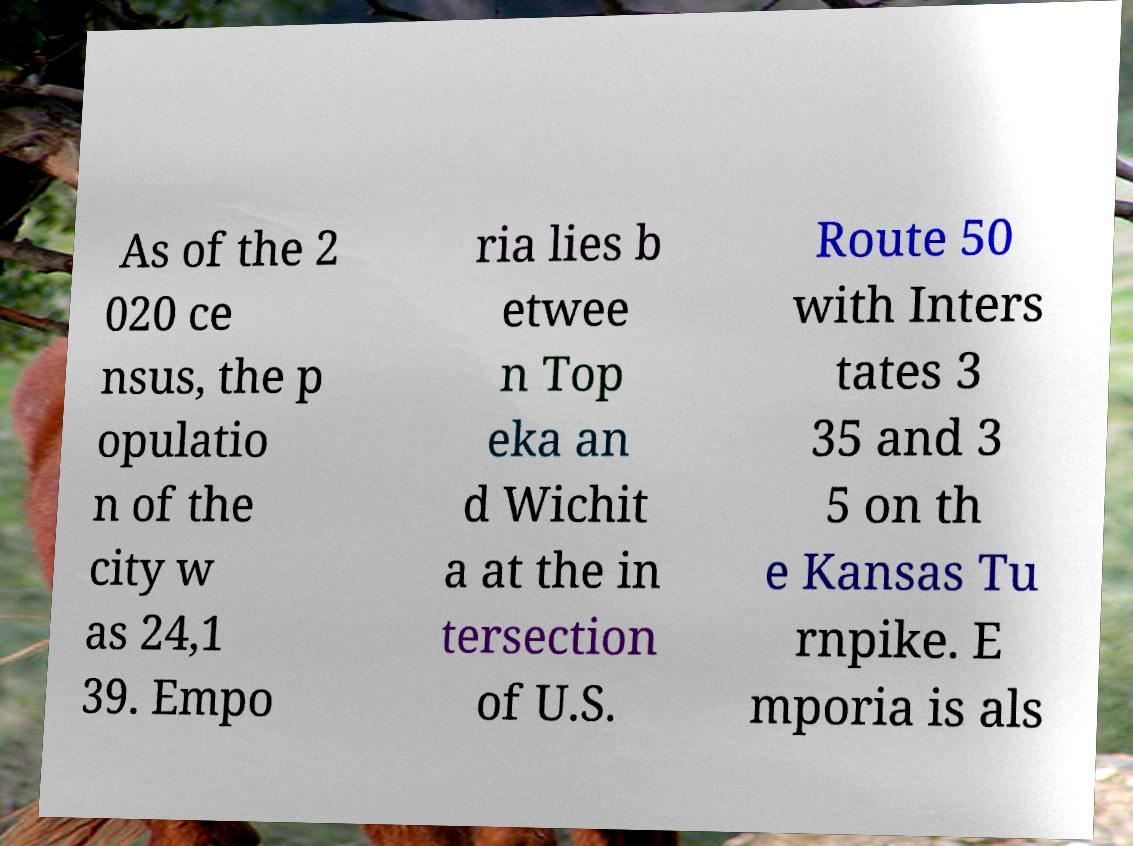Can you accurately transcribe the text from the provided image for me? As of the 2 020 ce nsus, the p opulatio n of the city w as 24,1 39. Empo ria lies b etwee n Top eka an d Wichit a at the in tersection of U.S. Route 50 with Inters tates 3 35 and 3 5 on th e Kansas Tu rnpike. E mporia is als 